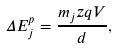Convert formula to latex. <formula><loc_0><loc_0><loc_500><loc_500>\Delta E _ { j } ^ { p } = \frac { m _ { j } z q V } { d } ,</formula> 